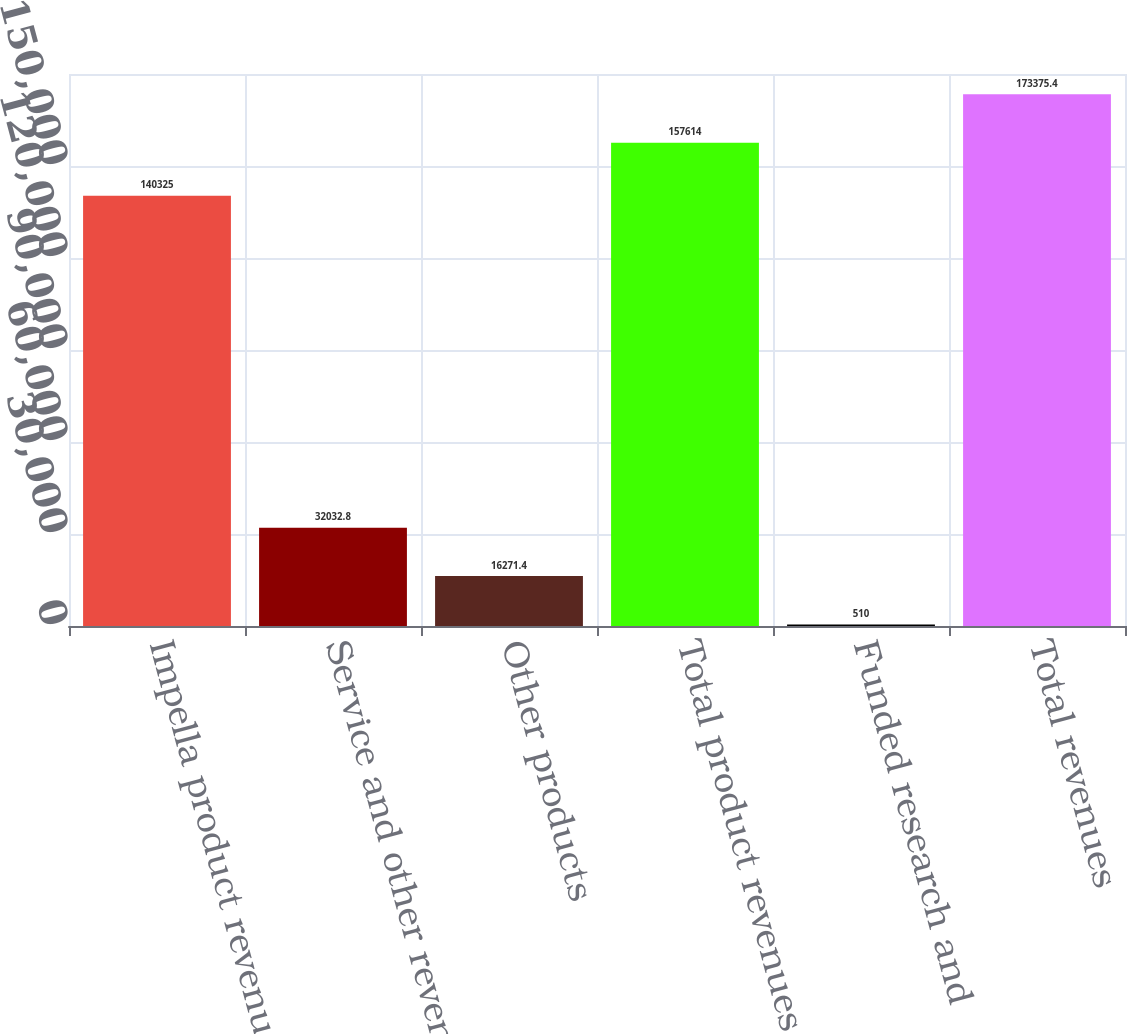<chart> <loc_0><loc_0><loc_500><loc_500><bar_chart><fcel>Impella product revenue<fcel>Service and other revenue<fcel>Other products<fcel>Total product revenues<fcel>Funded research and<fcel>Total revenues<nl><fcel>140325<fcel>32032.8<fcel>16271.4<fcel>157614<fcel>510<fcel>173375<nl></chart> 